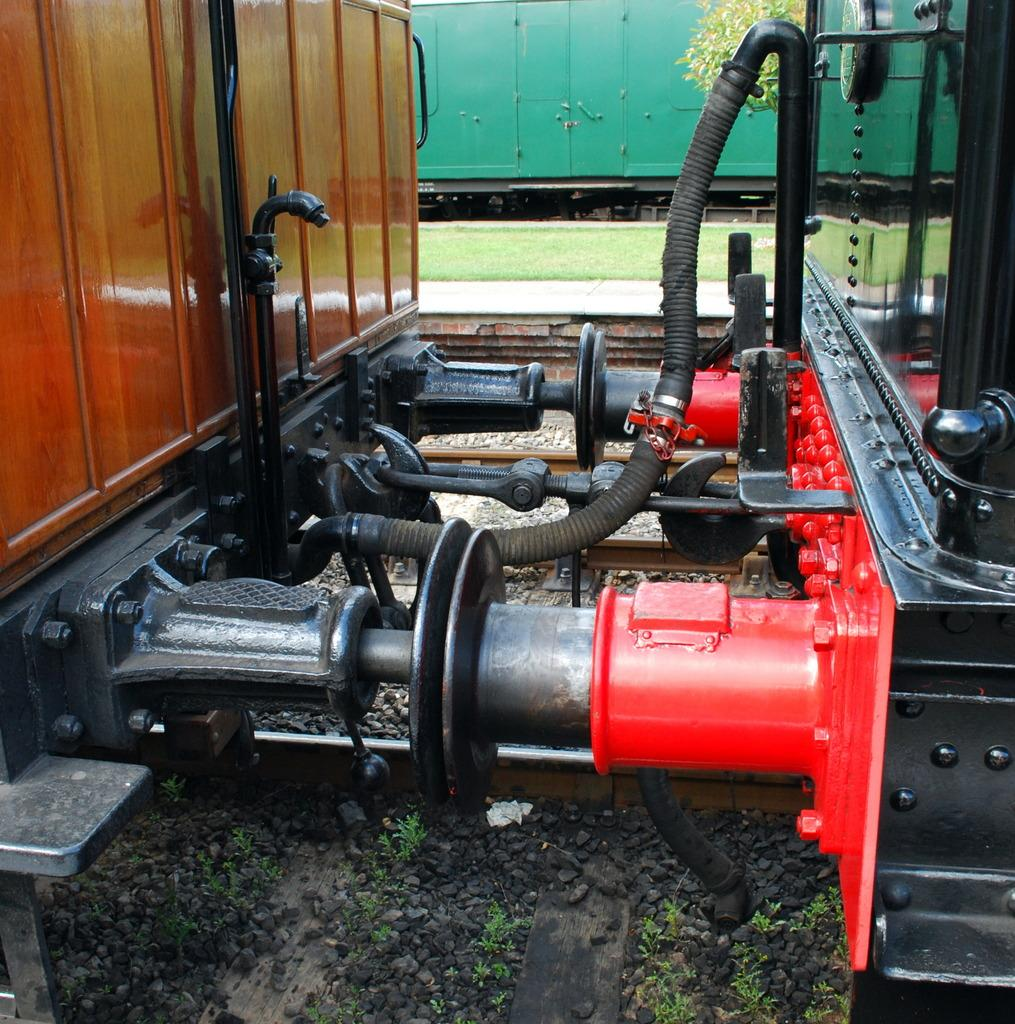What is the main subject of the image? The main subject of the image is a train. Can you describe the train's position in the image? The train is on a track. What type of natural environment can be seen in the background of the image? There is grass and plants in the background of the image. What type of toothbrush is visible in the image? There is no toothbrush present in the image. What is the train serving for dinner in the image? The image does not depict a train serving dinner; it simply shows a train on a track with grass and plants in the background. 